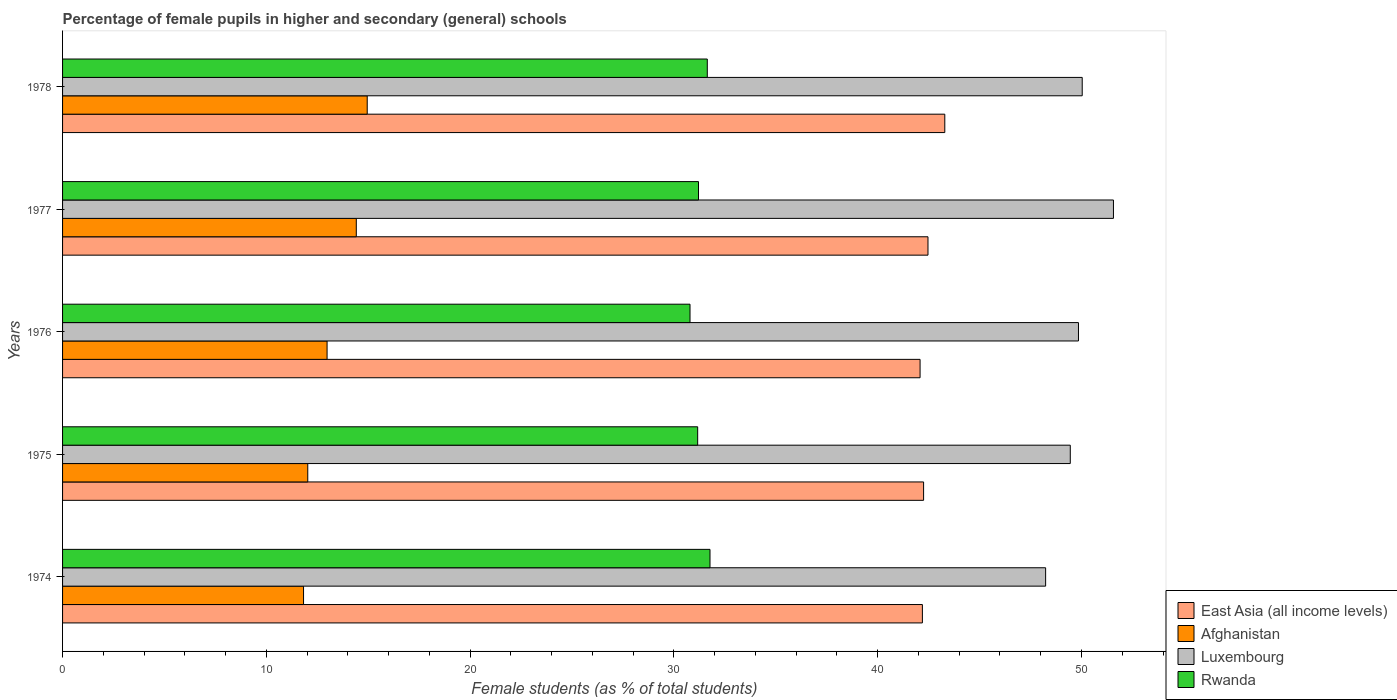How many different coloured bars are there?
Keep it short and to the point. 4. Are the number of bars per tick equal to the number of legend labels?
Offer a terse response. Yes. How many bars are there on the 5th tick from the bottom?
Give a very brief answer. 4. What is the label of the 4th group of bars from the top?
Provide a succinct answer. 1975. In how many cases, is the number of bars for a given year not equal to the number of legend labels?
Your response must be concise. 0. What is the percentage of female pupils in higher and secondary schools in East Asia (all income levels) in 1974?
Your answer should be compact. 42.19. Across all years, what is the maximum percentage of female pupils in higher and secondary schools in Rwanda?
Your answer should be compact. 31.77. Across all years, what is the minimum percentage of female pupils in higher and secondary schools in Rwanda?
Offer a very short reply. 30.79. In which year was the percentage of female pupils in higher and secondary schools in East Asia (all income levels) maximum?
Offer a terse response. 1978. In which year was the percentage of female pupils in higher and secondary schools in Afghanistan minimum?
Ensure brevity in your answer.  1974. What is the total percentage of female pupils in higher and secondary schools in East Asia (all income levels) in the graph?
Your answer should be compact. 212.29. What is the difference between the percentage of female pupils in higher and secondary schools in Luxembourg in 1974 and that in 1978?
Ensure brevity in your answer.  -1.8. What is the difference between the percentage of female pupils in higher and secondary schools in Luxembourg in 1978 and the percentage of female pupils in higher and secondary schools in East Asia (all income levels) in 1977?
Offer a terse response. 7.57. What is the average percentage of female pupils in higher and secondary schools in East Asia (all income levels) per year?
Your answer should be very brief. 42.46. In the year 1977, what is the difference between the percentage of female pupils in higher and secondary schools in Rwanda and percentage of female pupils in higher and secondary schools in East Asia (all income levels)?
Make the answer very short. -11.26. What is the ratio of the percentage of female pupils in higher and secondary schools in Rwanda in 1975 to that in 1977?
Offer a terse response. 1. Is the percentage of female pupils in higher and secondary schools in Afghanistan in 1975 less than that in 1976?
Ensure brevity in your answer.  Yes. What is the difference between the highest and the second highest percentage of female pupils in higher and secondary schools in East Asia (all income levels)?
Your answer should be very brief. 0.83. What is the difference between the highest and the lowest percentage of female pupils in higher and secondary schools in Luxembourg?
Give a very brief answer. 3.33. In how many years, is the percentage of female pupils in higher and secondary schools in Afghanistan greater than the average percentage of female pupils in higher and secondary schools in Afghanistan taken over all years?
Keep it short and to the point. 2. Is the sum of the percentage of female pupils in higher and secondary schools in Rwanda in 1976 and 1978 greater than the maximum percentage of female pupils in higher and secondary schools in Luxembourg across all years?
Make the answer very short. Yes. Is it the case that in every year, the sum of the percentage of female pupils in higher and secondary schools in Rwanda and percentage of female pupils in higher and secondary schools in Luxembourg is greater than the sum of percentage of female pupils in higher and secondary schools in Afghanistan and percentage of female pupils in higher and secondary schools in East Asia (all income levels)?
Keep it short and to the point. No. What does the 1st bar from the top in 1974 represents?
Keep it short and to the point. Rwanda. What does the 4th bar from the bottom in 1977 represents?
Your answer should be compact. Rwanda. How many bars are there?
Give a very brief answer. 20. How many years are there in the graph?
Keep it short and to the point. 5. How many legend labels are there?
Provide a succinct answer. 4. What is the title of the graph?
Offer a terse response. Percentage of female pupils in higher and secondary (general) schools. Does "Ethiopia" appear as one of the legend labels in the graph?
Offer a very short reply. No. What is the label or title of the X-axis?
Provide a short and direct response. Female students (as % of total students). What is the Female students (as % of total students) of East Asia (all income levels) in 1974?
Offer a very short reply. 42.19. What is the Female students (as % of total students) in Afghanistan in 1974?
Provide a short and direct response. 11.83. What is the Female students (as % of total students) in Luxembourg in 1974?
Your answer should be very brief. 48.24. What is the Female students (as % of total students) of Rwanda in 1974?
Your answer should be very brief. 31.77. What is the Female students (as % of total students) of East Asia (all income levels) in 1975?
Offer a terse response. 42.25. What is the Female students (as % of total students) in Afghanistan in 1975?
Make the answer very short. 12.03. What is the Female students (as % of total students) of Luxembourg in 1975?
Your answer should be compact. 49.45. What is the Female students (as % of total students) of Rwanda in 1975?
Provide a short and direct response. 31.17. What is the Female students (as % of total students) of East Asia (all income levels) in 1976?
Give a very brief answer. 42.08. What is the Female students (as % of total students) in Afghanistan in 1976?
Provide a short and direct response. 12.98. What is the Female students (as % of total students) of Luxembourg in 1976?
Make the answer very short. 49.85. What is the Female students (as % of total students) in Rwanda in 1976?
Keep it short and to the point. 30.79. What is the Female students (as % of total students) in East Asia (all income levels) in 1977?
Offer a terse response. 42.47. What is the Female students (as % of total students) of Afghanistan in 1977?
Provide a succinct answer. 14.41. What is the Female students (as % of total students) in Luxembourg in 1977?
Make the answer very short. 51.57. What is the Female students (as % of total students) of Rwanda in 1977?
Offer a terse response. 31.21. What is the Female students (as % of total students) of East Asia (all income levels) in 1978?
Your answer should be very brief. 43.29. What is the Female students (as % of total students) in Afghanistan in 1978?
Ensure brevity in your answer.  14.95. What is the Female students (as % of total students) in Luxembourg in 1978?
Give a very brief answer. 50.04. What is the Female students (as % of total students) of Rwanda in 1978?
Provide a succinct answer. 31.64. Across all years, what is the maximum Female students (as % of total students) in East Asia (all income levels)?
Your answer should be very brief. 43.29. Across all years, what is the maximum Female students (as % of total students) in Afghanistan?
Your response must be concise. 14.95. Across all years, what is the maximum Female students (as % of total students) of Luxembourg?
Your answer should be very brief. 51.57. Across all years, what is the maximum Female students (as % of total students) in Rwanda?
Provide a succinct answer. 31.77. Across all years, what is the minimum Female students (as % of total students) in East Asia (all income levels)?
Offer a very short reply. 42.08. Across all years, what is the minimum Female students (as % of total students) of Afghanistan?
Your answer should be compact. 11.83. Across all years, what is the minimum Female students (as % of total students) in Luxembourg?
Give a very brief answer. 48.24. Across all years, what is the minimum Female students (as % of total students) of Rwanda?
Offer a very short reply. 30.79. What is the total Female students (as % of total students) of East Asia (all income levels) in the graph?
Provide a short and direct response. 212.29. What is the total Female students (as % of total students) in Afghanistan in the graph?
Provide a short and direct response. 66.2. What is the total Female students (as % of total students) of Luxembourg in the graph?
Give a very brief answer. 249.15. What is the total Female students (as % of total students) in Rwanda in the graph?
Your answer should be very brief. 156.57. What is the difference between the Female students (as % of total students) in East Asia (all income levels) in 1974 and that in 1975?
Your answer should be compact. -0.06. What is the difference between the Female students (as % of total students) of Afghanistan in 1974 and that in 1975?
Provide a succinct answer. -0.21. What is the difference between the Female students (as % of total students) of Luxembourg in 1974 and that in 1975?
Offer a very short reply. -1.21. What is the difference between the Female students (as % of total students) of Rwanda in 1974 and that in 1975?
Offer a terse response. 0.61. What is the difference between the Female students (as % of total students) in East Asia (all income levels) in 1974 and that in 1976?
Ensure brevity in your answer.  0.11. What is the difference between the Female students (as % of total students) in Afghanistan in 1974 and that in 1976?
Ensure brevity in your answer.  -1.16. What is the difference between the Female students (as % of total students) of Luxembourg in 1974 and that in 1976?
Give a very brief answer. -1.61. What is the difference between the Female students (as % of total students) of Rwanda in 1974 and that in 1976?
Keep it short and to the point. 0.98. What is the difference between the Female students (as % of total students) of East Asia (all income levels) in 1974 and that in 1977?
Make the answer very short. -0.27. What is the difference between the Female students (as % of total students) in Afghanistan in 1974 and that in 1977?
Provide a succinct answer. -2.59. What is the difference between the Female students (as % of total students) of Luxembourg in 1974 and that in 1977?
Keep it short and to the point. -3.33. What is the difference between the Female students (as % of total students) of Rwanda in 1974 and that in 1977?
Your answer should be very brief. 0.56. What is the difference between the Female students (as % of total students) of East Asia (all income levels) in 1974 and that in 1978?
Provide a short and direct response. -1.1. What is the difference between the Female students (as % of total students) in Afghanistan in 1974 and that in 1978?
Give a very brief answer. -3.12. What is the difference between the Female students (as % of total students) in Luxembourg in 1974 and that in 1978?
Your response must be concise. -1.8. What is the difference between the Female students (as % of total students) in Rwanda in 1974 and that in 1978?
Give a very brief answer. 0.13. What is the difference between the Female students (as % of total students) of East Asia (all income levels) in 1975 and that in 1976?
Keep it short and to the point. 0.17. What is the difference between the Female students (as % of total students) in Afghanistan in 1975 and that in 1976?
Give a very brief answer. -0.95. What is the difference between the Female students (as % of total students) of Luxembourg in 1975 and that in 1976?
Your response must be concise. -0.4. What is the difference between the Female students (as % of total students) in Rwanda in 1975 and that in 1976?
Your answer should be very brief. 0.38. What is the difference between the Female students (as % of total students) of East Asia (all income levels) in 1975 and that in 1977?
Ensure brevity in your answer.  -0.21. What is the difference between the Female students (as % of total students) of Afghanistan in 1975 and that in 1977?
Your response must be concise. -2.38. What is the difference between the Female students (as % of total students) in Luxembourg in 1975 and that in 1977?
Keep it short and to the point. -2.12. What is the difference between the Female students (as % of total students) in Rwanda in 1975 and that in 1977?
Your answer should be very brief. -0.04. What is the difference between the Female students (as % of total students) of East Asia (all income levels) in 1975 and that in 1978?
Offer a terse response. -1.04. What is the difference between the Female students (as % of total students) in Afghanistan in 1975 and that in 1978?
Your response must be concise. -2.92. What is the difference between the Female students (as % of total students) of Luxembourg in 1975 and that in 1978?
Offer a very short reply. -0.59. What is the difference between the Female students (as % of total students) in Rwanda in 1975 and that in 1978?
Offer a very short reply. -0.47. What is the difference between the Female students (as % of total students) in East Asia (all income levels) in 1976 and that in 1977?
Provide a short and direct response. -0.39. What is the difference between the Female students (as % of total students) of Afghanistan in 1976 and that in 1977?
Make the answer very short. -1.43. What is the difference between the Female students (as % of total students) of Luxembourg in 1976 and that in 1977?
Offer a terse response. -1.72. What is the difference between the Female students (as % of total students) of Rwanda in 1976 and that in 1977?
Give a very brief answer. -0.42. What is the difference between the Female students (as % of total students) of East Asia (all income levels) in 1976 and that in 1978?
Your response must be concise. -1.21. What is the difference between the Female students (as % of total students) in Afghanistan in 1976 and that in 1978?
Offer a terse response. -1.97. What is the difference between the Female students (as % of total students) of Luxembourg in 1976 and that in 1978?
Give a very brief answer. -0.18. What is the difference between the Female students (as % of total students) of Rwanda in 1976 and that in 1978?
Your answer should be very brief. -0.85. What is the difference between the Female students (as % of total students) in East Asia (all income levels) in 1977 and that in 1978?
Provide a short and direct response. -0.83. What is the difference between the Female students (as % of total students) in Afghanistan in 1977 and that in 1978?
Offer a very short reply. -0.54. What is the difference between the Female students (as % of total students) of Luxembourg in 1977 and that in 1978?
Offer a very short reply. 1.53. What is the difference between the Female students (as % of total students) of Rwanda in 1977 and that in 1978?
Ensure brevity in your answer.  -0.43. What is the difference between the Female students (as % of total students) of East Asia (all income levels) in 1974 and the Female students (as % of total students) of Afghanistan in 1975?
Keep it short and to the point. 30.16. What is the difference between the Female students (as % of total students) in East Asia (all income levels) in 1974 and the Female students (as % of total students) in Luxembourg in 1975?
Provide a succinct answer. -7.26. What is the difference between the Female students (as % of total students) of East Asia (all income levels) in 1974 and the Female students (as % of total students) of Rwanda in 1975?
Your answer should be compact. 11.03. What is the difference between the Female students (as % of total students) of Afghanistan in 1974 and the Female students (as % of total students) of Luxembourg in 1975?
Your answer should be very brief. -37.63. What is the difference between the Female students (as % of total students) in Afghanistan in 1974 and the Female students (as % of total students) in Rwanda in 1975?
Offer a very short reply. -19.34. What is the difference between the Female students (as % of total students) in Luxembourg in 1974 and the Female students (as % of total students) in Rwanda in 1975?
Give a very brief answer. 17.07. What is the difference between the Female students (as % of total students) of East Asia (all income levels) in 1974 and the Female students (as % of total students) of Afghanistan in 1976?
Your answer should be very brief. 29.21. What is the difference between the Female students (as % of total students) of East Asia (all income levels) in 1974 and the Female students (as % of total students) of Luxembourg in 1976?
Give a very brief answer. -7.66. What is the difference between the Female students (as % of total students) in East Asia (all income levels) in 1974 and the Female students (as % of total students) in Rwanda in 1976?
Provide a succinct answer. 11.4. What is the difference between the Female students (as % of total students) in Afghanistan in 1974 and the Female students (as % of total students) in Luxembourg in 1976?
Keep it short and to the point. -38.03. What is the difference between the Female students (as % of total students) in Afghanistan in 1974 and the Female students (as % of total students) in Rwanda in 1976?
Offer a very short reply. -18.97. What is the difference between the Female students (as % of total students) in Luxembourg in 1974 and the Female students (as % of total students) in Rwanda in 1976?
Provide a short and direct response. 17.45. What is the difference between the Female students (as % of total students) in East Asia (all income levels) in 1974 and the Female students (as % of total students) in Afghanistan in 1977?
Ensure brevity in your answer.  27.78. What is the difference between the Female students (as % of total students) of East Asia (all income levels) in 1974 and the Female students (as % of total students) of Luxembourg in 1977?
Offer a terse response. -9.38. What is the difference between the Female students (as % of total students) in East Asia (all income levels) in 1974 and the Female students (as % of total students) in Rwanda in 1977?
Provide a succinct answer. 10.99. What is the difference between the Female students (as % of total students) in Afghanistan in 1974 and the Female students (as % of total students) in Luxembourg in 1977?
Your answer should be very brief. -39.74. What is the difference between the Female students (as % of total students) in Afghanistan in 1974 and the Female students (as % of total students) in Rwanda in 1977?
Give a very brief answer. -19.38. What is the difference between the Female students (as % of total students) in Luxembourg in 1974 and the Female students (as % of total students) in Rwanda in 1977?
Offer a very short reply. 17.03. What is the difference between the Female students (as % of total students) in East Asia (all income levels) in 1974 and the Female students (as % of total students) in Afghanistan in 1978?
Ensure brevity in your answer.  27.24. What is the difference between the Female students (as % of total students) of East Asia (all income levels) in 1974 and the Female students (as % of total students) of Luxembourg in 1978?
Ensure brevity in your answer.  -7.84. What is the difference between the Female students (as % of total students) of East Asia (all income levels) in 1974 and the Female students (as % of total students) of Rwanda in 1978?
Offer a terse response. 10.56. What is the difference between the Female students (as % of total students) in Afghanistan in 1974 and the Female students (as % of total students) in Luxembourg in 1978?
Ensure brevity in your answer.  -38.21. What is the difference between the Female students (as % of total students) of Afghanistan in 1974 and the Female students (as % of total students) of Rwanda in 1978?
Make the answer very short. -19.81. What is the difference between the Female students (as % of total students) in Luxembourg in 1974 and the Female students (as % of total students) in Rwanda in 1978?
Provide a short and direct response. 16.6. What is the difference between the Female students (as % of total students) in East Asia (all income levels) in 1975 and the Female students (as % of total students) in Afghanistan in 1976?
Provide a succinct answer. 29.27. What is the difference between the Female students (as % of total students) in East Asia (all income levels) in 1975 and the Female students (as % of total students) in Luxembourg in 1976?
Offer a very short reply. -7.6. What is the difference between the Female students (as % of total students) of East Asia (all income levels) in 1975 and the Female students (as % of total students) of Rwanda in 1976?
Provide a succinct answer. 11.46. What is the difference between the Female students (as % of total students) in Afghanistan in 1975 and the Female students (as % of total students) in Luxembourg in 1976?
Your answer should be compact. -37.82. What is the difference between the Female students (as % of total students) of Afghanistan in 1975 and the Female students (as % of total students) of Rwanda in 1976?
Offer a very short reply. -18.76. What is the difference between the Female students (as % of total students) in Luxembourg in 1975 and the Female students (as % of total students) in Rwanda in 1976?
Make the answer very short. 18.66. What is the difference between the Female students (as % of total students) of East Asia (all income levels) in 1975 and the Female students (as % of total students) of Afghanistan in 1977?
Your answer should be very brief. 27.84. What is the difference between the Female students (as % of total students) of East Asia (all income levels) in 1975 and the Female students (as % of total students) of Luxembourg in 1977?
Your response must be concise. -9.32. What is the difference between the Female students (as % of total students) in East Asia (all income levels) in 1975 and the Female students (as % of total students) in Rwanda in 1977?
Ensure brevity in your answer.  11.05. What is the difference between the Female students (as % of total students) in Afghanistan in 1975 and the Female students (as % of total students) in Luxembourg in 1977?
Make the answer very short. -39.54. What is the difference between the Female students (as % of total students) in Afghanistan in 1975 and the Female students (as % of total students) in Rwanda in 1977?
Your response must be concise. -19.17. What is the difference between the Female students (as % of total students) in Luxembourg in 1975 and the Female students (as % of total students) in Rwanda in 1977?
Your response must be concise. 18.24. What is the difference between the Female students (as % of total students) of East Asia (all income levels) in 1975 and the Female students (as % of total students) of Afghanistan in 1978?
Offer a terse response. 27.3. What is the difference between the Female students (as % of total students) in East Asia (all income levels) in 1975 and the Female students (as % of total students) in Luxembourg in 1978?
Ensure brevity in your answer.  -7.78. What is the difference between the Female students (as % of total students) of East Asia (all income levels) in 1975 and the Female students (as % of total students) of Rwanda in 1978?
Your response must be concise. 10.61. What is the difference between the Female students (as % of total students) of Afghanistan in 1975 and the Female students (as % of total students) of Luxembourg in 1978?
Provide a succinct answer. -38. What is the difference between the Female students (as % of total students) in Afghanistan in 1975 and the Female students (as % of total students) in Rwanda in 1978?
Your answer should be very brief. -19.61. What is the difference between the Female students (as % of total students) of Luxembourg in 1975 and the Female students (as % of total students) of Rwanda in 1978?
Keep it short and to the point. 17.81. What is the difference between the Female students (as % of total students) of East Asia (all income levels) in 1976 and the Female students (as % of total students) of Afghanistan in 1977?
Keep it short and to the point. 27.67. What is the difference between the Female students (as % of total students) of East Asia (all income levels) in 1976 and the Female students (as % of total students) of Luxembourg in 1977?
Provide a short and direct response. -9.49. What is the difference between the Female students (as % of total students) of East Asia (all income levels) in 1976 and the Female students (as % of total students) of Rwanda in 1977?
Provide a short and direct response. 10.87. What is the difference between the Female students (as % of total students) in Afghanistan in 1976 and the Female students (as % of total students) in Luxembourg in 1977?
Ensure brevity in your answer.  -38.59. What is the difference between the Female students (as % of total students) of Afghanistan in 1976 and the Female students (as % of total students) of Rwanda in 1977?
Your answer should be compact. -18.23. What is the difference between the Female students (as % of total students) in Luxembourg in 1976 and the Female students (as % of total students) in Rwanda in 1977?
Ensure brevity in your answer.  18.65. What is the difference between the Female students (as % of total students) of East Asia (all income levels) in 1976 and the Female students (as % of total students) of Afghanistan in 1978?
Ensure brevity in your answer.  27.13. What is the difference between the Female students (as % of total students) of East Asia (all income levels) in 1976 and the Female students (as % of total students) of Luxembourg in 1978?
Offer a very short reply. -7.96. What is the difference between the Female students (as % of total students) in East Asia (all income levels) in 1976 and the Female students (as % of total students) in Rwanda in 1978?
Give a very brief answer. 10.44. What is the difference between the Female students (as % of total students) of Afghanistan in 1976 and the Female students (as % of total students) of Luxembourg in 1978?
Your answer should be very brief. -37.06. What is the difference between the Female students (as % of total students) of Afghanistan in 1976 and the Female students (as % of total students) of Rwanda in 1978?
Give a very brief answer. -18.66. What is the difference between the Female students (as % of total students) of Luxembourg in 1976 and the Female students (as % of total students) of Rwanda in 1978?
Provide a short and direct response. 18.21. What is the difference between the Female students (as % of total students) in East Asia (all income levels) in 1977 and the Female students (as % of total students) in Afghanistan in 1978?
Provide a short and direct response. 27.52. What is the difference between the Female students (as % of total students) of East Asia (all income levels) in 1977 and the Female students (as % of total students) of Luxembourg in 1978?
Your answer should be very brief. -7.57. What is the difference between the Female students (as % of total students) of East Asia (all income levels) in 1977 and the Female students (as % of total students) of Rwanda in 1978?
Offer a terse response. 10.83. What is the difference between the Female students (as % of total students) in Afghanistan in 1977 and the Female students (as % of total students) in Luxembourg in 1978?
Your response must be concise. -35.62. What is the difference between the Female students (as % of total students) of Afghanistan in 1977 and the Female students (as % of total students) of Rwanda in 1978?
Offer a terse response. -17.22. What is the difference between the Female students (as % of total students) in Luxembourg in 1977 and the Female students (as % of total students) in Rwanda in 1978?
Make the answer very short. 19.93. What is the average Female students (as % of total students) in East Asia (all income levels) per year?
Give a very brief answer. 42.46. What is the average Female students (as % of total students) in Afghanistan per year?
Keep it short and to the point. 13.24. What is the average Female students (as % of total students) in Luxembourg per year?
Ensure brevity in your answer.  49.83. What is the average Female students (as % of total students) of Rwanda per year?
Your response must be concise. 31.31. In the year 1974, what is the difference between the Female students (as % of total students) in East Asia (all income levels) and Female students (as % of total students) in Afghanistan?
Your answer should be very brief. 30.37. In the year 1974, what is the difference between the Female students (as % of total students) in East Asia (all income levels) and Female students (as % of total students) in Luxembourg?
Provide a short and direct response. -6.05. In the year 1974, what is the difference between the Female students (as % of total students) of East Asia (all income levels) and Female students (as % of total students) of Rwanda?
Offer a terse response. 10.42. In the year 1974, what is the difference between the Female students (as % of total students) of Afghanistan and Female students (as % of total students) of Luxembourg?
Give a very brief answer. -36.42. In the year 1974, what is the difference between the Female students (as % of total students) of Afghanistan and Female students (as % of total students) of Rwanda?
Give a very brief answer. -19.95. In the year 1974, what is the difference between the Female students (as % of total students) in Luxembourg and Female students (as % of total students) in Rwanda?
Offer a terse response. 16.47. In the year 1975, what is the difference between the Female students (as % of total students) of East Asia (all income levels) and Female students (as % of total students) of Afghanistan?
Keep it short and to the point. 30.22. In the year 1975, what is the difference between the Female students (as % of total students) of East Asia (all income levels) and Female students (as % of total students) of Luxembourg?
Ensure brevity in your answer.  -7.2. In the year 1975, what is the difference between the Female students (as % of total students) of East Asia (all income levels) and Female students (as % of total students) of Rwanda?
Keep it short and to the point. 11.09. In the year 1975, what is the difference between the Female students (as % of total students) of Afghanistan and Female students (as % of total students) of Luxembourg?
Offer a very short reply. -37.42. In the year 1975, what is the difference between the Female students (as % of total students) in Afghanistan and Female students (as % of total students) in Rwanda?
Provide a short and direct response. -19.13. In the year 1975, what is the difference between the Female students (as % of total students) of Luxembourg and Female students (as % of total students) of Rwanda?
Give a very brief answer. 18.28. In the year 1976, what is the difference between the Female students (as % of total students) in East Asia (all income levels) and Female students (as % of total students) in Afghanistan?
Make the answer very short. 29.1. In the year 1976, what is the difference between the Female students (as % of total students) in East Asia (all income levels) and Female students (as % of total students) in Luxembourg?
Your response must be concise. -7.77. In the year 1976, what is the difference between the Female students (as % of total students) of East Asia (all income levels) and Female students (as % of total students) of Rwanda?
Give a very brief answer. 11.29. In the year 1976, what is the difference between the Female students (as % of total students) in Afghanistan and Female students (as % of total students) in Luxembourg?
Your answer should be very brief. -36.87. In the year 1976, what is the difference between the Female students (as % of total students) in Afghanistan and Female students (as % of total students) in Rwanda?
Your answer should be compact. -17.81. In the year 1976, what is the difference between the Female students (as % of total students) of Luxembourg and Female students (as % of total students) of Rwanda?
Offer a terse response. 19.06. In the year 1977, what is the difference between the Female students (as % of total students) of East Asia (all income levels) and Female students (as % of total students) of Afghanistan?
Your answer should be very brief. 28.05. In the year 1977, what is the difference between the Female students (as % of total students) in East Asia (all income levels) and Female students (as % of total students) in Luxembourg?
Your answer should be compact. -9.1. In the year 1977, what is the difference between the Female students (as % of total students) of East Asia (all income levels) and Female students (as % of total students) of Rwanda?
Offer a terse response. 11.26. In the year 1977, what is the difference between the Female students (as % of total students) in Afghanistan and Female students (as % of total students) in Luxembourg?
Offer a very short reply. -37.15. In the year 1977, what is the difference between the Female students (as % of total students) of Afghanistan and Female students (as % of total students) of Rwanda?
Make the answer very short. -16.79. In the year 1977, what is the difference between the Female students (as % of total students) of Luxembourg and Female students (as % of total students) of Rwanda?
Offer a terse response. 20.36. In the year 1978, what is the difference between the Female students (as % of total students) in East Asia (all income levels) and Female students (as % of total students) in Afghanistan?
Offer a terse response. 28.34. In the year 1978, what is the difference between the Female students (as % of total students) in East Asia (all income levels) and Female students (as % of total students) in Luxembourg?
Ensure brevity in your answer.  -6.74. In the year 1978, what is the difference between the Female students (as % of total students) in East Asia (all income levels) and Female students (as % of total students) in Rwanda?
Your response must be concise. 11.65. In the year 1978, what is the difference between the Female students (as % of total students) of Afghanistan and Female students (as % of total students) of Luxembourg?
Make the answer very short. -35.09. In the year 1978, what is the difference between the Female students (as % of total students) in Afghanistan and Female students (as % of total students) in Rwanda?
Give a very brief answer. -16.69. In the year 1978, what is the difference between the Female students (as % of total students) in Luxembourg and Female students (as % of total students) in Rwanda?
Keep it short and to the point. 18.4. What is the ratio of the Female students (as % of total students) in East Asia (all income levels) in 1974 to that in 1975?
Offer a terse response. 1. What is the ratio of the Female students (as % of total students) in Afghanistan in 1974 to that in 1975?
Ensure brevity in your answer.  0.98. What is the ratio of the Female students (as % of total students) of Luxembourg in 1974 to that in 1975?
Provide a succinct answer. 0.98. What is the ratio of the Female students (as % of total students) of Rwanda in 1974 to that in 1975?
Keep it short and to the point. 1.02. What is the ratio of the Female students (as % of total students) in Afghanistan in 1974 to that in 1976?
Make the answer very short. 0.91. What is the ratio of the Female students (as % of total students) in Luxembourg in 1974 to that in 1976?
Offer a terse response. 0.97. What is the ratio of the Female students (as % of total students) in Rwanda in 1974 to that in 1976?
Make the answer very short. 1.03. What is the ratio of the Female students (as % of total students) in Afghanistan in 1974 to that in 1977?
Keep it short and to the point. 0.82. What is the ratio of the Female students (as % of total students) of Luxembourg in 1974 to that in 1977?
Make the answer very short. 0.94. What is the ratio of the Female students (as % of total students) in Rwanda in 1974 to that in 1977?
Your response must be concise. 1.02. What is the ratio of the Female students (as % of total students) in East Asia (all income levels) in 1974 to that in 1978?
Ensure brevity in your answer.  0.97. What is the ratio of the Female students (as % of total students) of Afghanistan in 1974 to that in 1978?
Provide a succinct answer. 0.79. What is the ratio of the Female students (as % of total students) in Luxembourg in 1974 to that in 1978?
Your answer should be compact. 0.96. What is the ratio of the Female students (as % of total students) of Afghanistan in 1975 to that in 1976?
Your answer should be very brief. 0.93. What is the ratio of the Female students (as % of total students) of Luxembourg in 1975 to that in 1976?
Your response must be concise. 0.99. What is the ratio of the Female students (as % of total students) of Rwanda in 1975 to that in 1976?
Your answer should be compact. 1.01. What is the ratio of the Female students (as % of total students) in East Asia (all income levels) in 1975 to that in 1977?
Offer a terse response. 0.99. What is the ratio of the Female students (as % of total students) of Afghanistan in 1975 to that in 1977?
Provide a succinct answer. 0.83. What is the ratio of the Female students (as % of total students) in Luxembourg in 1975 to that in 1977?
Offer a terse response. 0.96. What is the ratio of the Female students (as % of total students) of Rwanda in 1975 to that in 1977?
Provide a short and direct response. 1. What is the ratio of the Female students (as % of total students) in Afghanistan in 1975 to that in 1978?
Make the answer very short. 0.8. What is the ratio of the Female students (as % of total students) of Luxembourg in 1975 to that in 1978?
Give a very brief answer. 0.99. What is the ratio of the Female students (as % of total students) of Rwanda in 1975 to that in 1978?
Provide a succinct answer. 0.99. What is the ratio of the Female students (as % of total students) in East Asia (all income levels) in 1976 to that in 1977?
Your answer should be compact. 0.99. What is the ratio of the Female students (as % of total students) in Afghanistan in 1976 to that in 1977?
Make the answer very short. 0.9. What is the ratio of the Female students (as % of total students) of Luxembourg in 1976 to that in 1977?
Your response must be concise. 0.97. What is the ratio of the Female students (as % of total students) in Rwanda in 1976 to that in 1977?
Offer a terse response. 0.99. What is the ratio of the Female students (as % of total students) in Afghanistan in 1976 to that in 1978?
Provide a succinct answer. 0.87. What is the ratio of the Female students (as % of total students) in Luxembourg in 1976 to that in 1978?
Your answer should be very brief. 1. What is the ratio of the Female students (as % of total students) in Rwanda in 1976 to that in 1978?
Keep it short and to the point. 0.97. What is the ratio of the Female students (as % of total students) in East Asia (all income levels) in 1977 to that in 1978?
Provide a succinct answer. 0.98. What is the ratio of the Female students (as % of total students) of Afghanistan in 1977 to that in 1978?
Give a very brief answer. 0.96. What is the ratio of the Female students (as % of total students) of Luxembourg in 1977 to that in 1978?
Make the answer very short. 1.03. What is the ratio of the Female students (as % of total students) in Rwanda in 1977 to that in 1978?
Your response must be concise. 0.99. What is the difference between the highest and the second highest Female students (as % of total students) of East Asia (all income levels)?
Provide a succinct answer. 0.83. What is the difference between the highest and the second highest Female students (as % of total students) of Afghanistan?
Keep it short and to the point. 0.54. What is the difference between the highest and the second highest Female students (as % of total students) in Luxembourg?
Make the answer very short. 1.53. What is the difference between the highest and the second highest Female students (as % of total students) in Rwanda?
Your response must be concise. 0.13. What is the difference between the highest and the lowest Female students (as % of total students) of East Asia (all income levels)?
Keep it short and to the point. 1.21. What is the difference between the highest and the lowest Female students (as % of total students) of Afghanistan?
Your answer should be compact. 3.12. What is the difference between the highest and the lowest Female students (as % of total students) in Luxembourg?
Your answer should be very brief. 3.33. What is the difference between the highest and the lowest Female students (as % of total students) of Rwanda?
Offer a terse response. 0.98. 